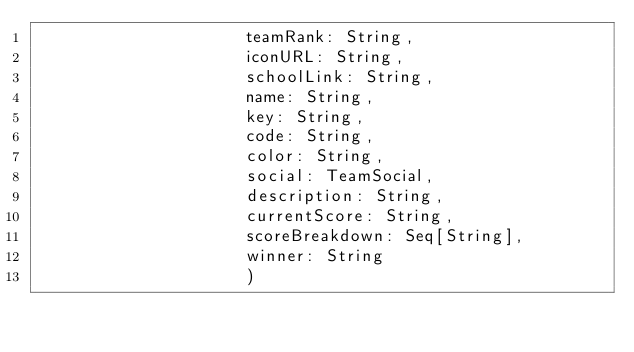Convert code to text. <code><loc_0><loc_0><loc_500><loc_500><_Scala_>                     teamRank: String,
                     iconURL: String,
                     schoolLink: String,
                     name: String,
                     key: String,
                     code: String,
                     color: String,
                     social: TeamSocial,
                     description: String,
                     currentScore: String,
                     scoreBreakdown: Seq[String],
                     winner: String
                     )</code> 